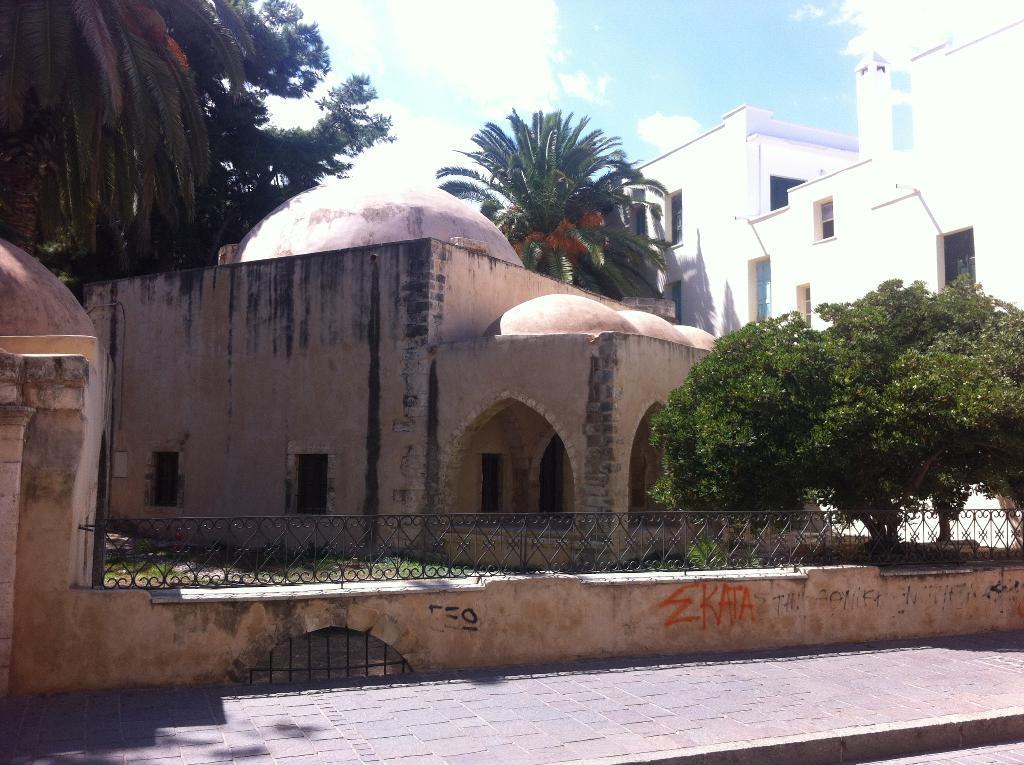Please provide a concise description of this image. In this picture we can see a footpath, fence, trees, grass, buildings with windows, walls and in the background we can see the sky with clouds. 